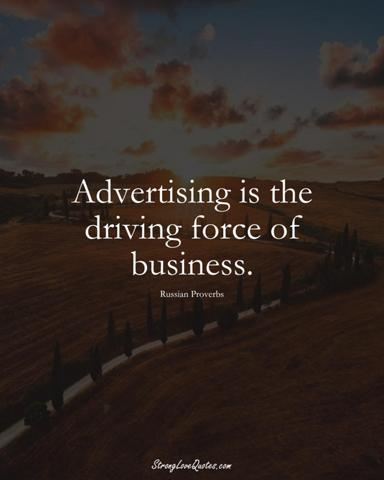What does the phrase "Advertising is the driving force of business" mean? The phrase 'Advertising is the driving force of business' underscores the pivotal role advertising plays in propelling commercial activities. Effective advertising campaigns are instrumental in capturing consumer interest, differentiating products in a competitive market, and forging a memorable brand identity. By relaying persuasive messages that resonate with a target audience, advertising serves as the catalyst for business growth, steers consumer behavior, and drives sales. Drawing parallels with the image, just as a road facilitates movement, strategic advertising channels drive the circulation of commerce, leading businesses toward their goals. 